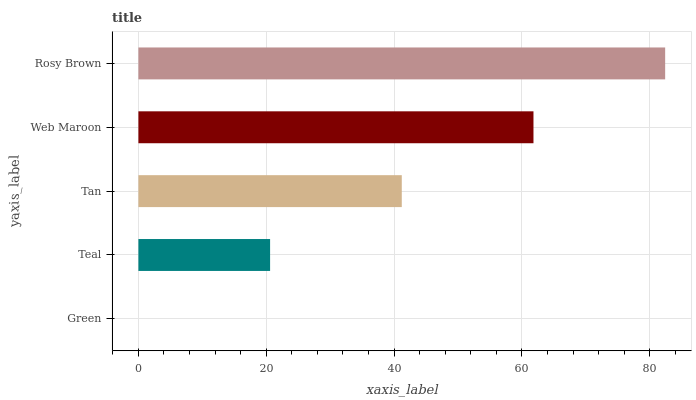Is Green the minimum?
Answer yes or no. Yes. Is Rosy Brown the maximum?
Answer yes or no. Yes. Is Teal the minimum?
Answer yes or no. No. Is Teal the maximum?
Answer yes or no. No. Is Teal greater than Green?
Answer yes or no. Yes. Is Green less than Teal?
Answer yes or no. Yes. Is Green greater than Teal?
Answer yes or no. No. Is Teal less than Green?
Answer yes or no. No. Is Tan the high median?
Answer yes or no. Yes. Is Tan the low median?
Answer yes or no. Yes. Is Teal the high median?
Answer yes or no. No. Is Green the low median?
Answer yes or no. No. 